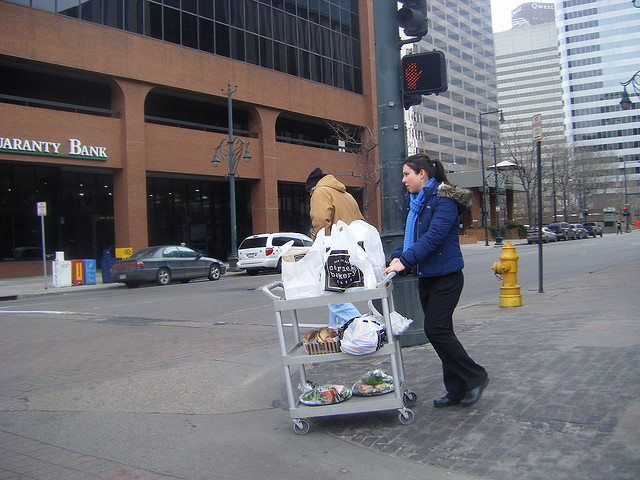<image>Who does the lady see coming from a distance? I am not sure who the lady sees coming from a distance. It could be a car or a person. Is this the United States? It is ambiguous whether this is the United States or not without further context. Who does the lady see coming from a distance? The lady sees a car coming from a distance. Is this the United States? I don't know if this is the United States. It can be the United States or it can be another country. 